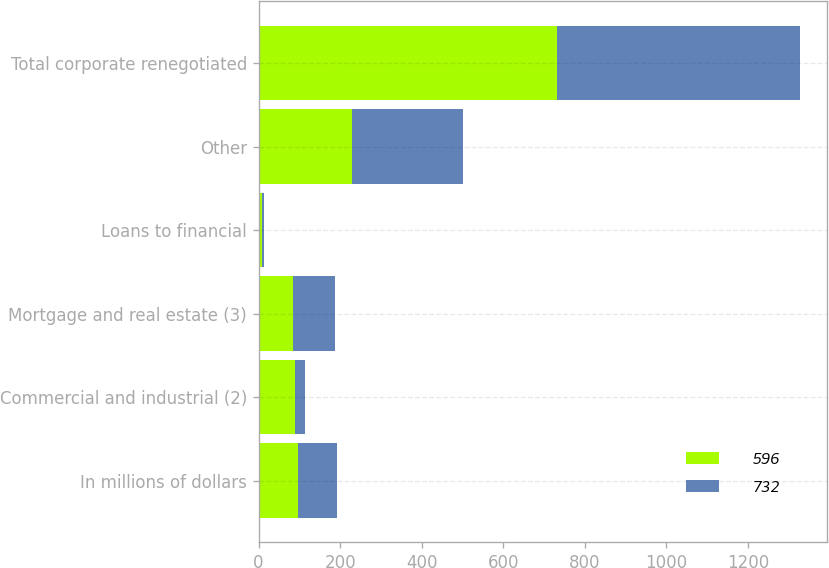Convert chart. <chart><loc_0><loc_0><loc_500><loc_500><stacked_bar_chart><ecel><fcel>In millions of dollars<fcel>Commercial and industrial (2)<fcel>Mortgage and real estate (3)<fcel>Loans to financial<fcel>Other<fcel>Total corporate renegotiated<nl><fcel>596<fcel>96.5<fcel>89<fcel>84<fcel>9<fcel>228<fcel>732<nl><fcel>732<fcel>96.5<fcel>25<fcel>104<fcel>5<fcel>273<fcel>596<nl></chart> 